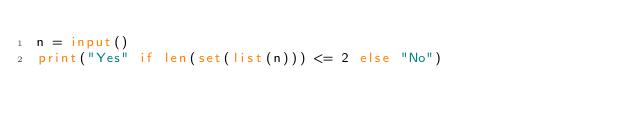Convert code to text. <code><loc_0><loc_0><loc_500><loc_500><_Python_>n = input()
print("Yes" if len(set(list(n))) <= 2 else "No")</code> 